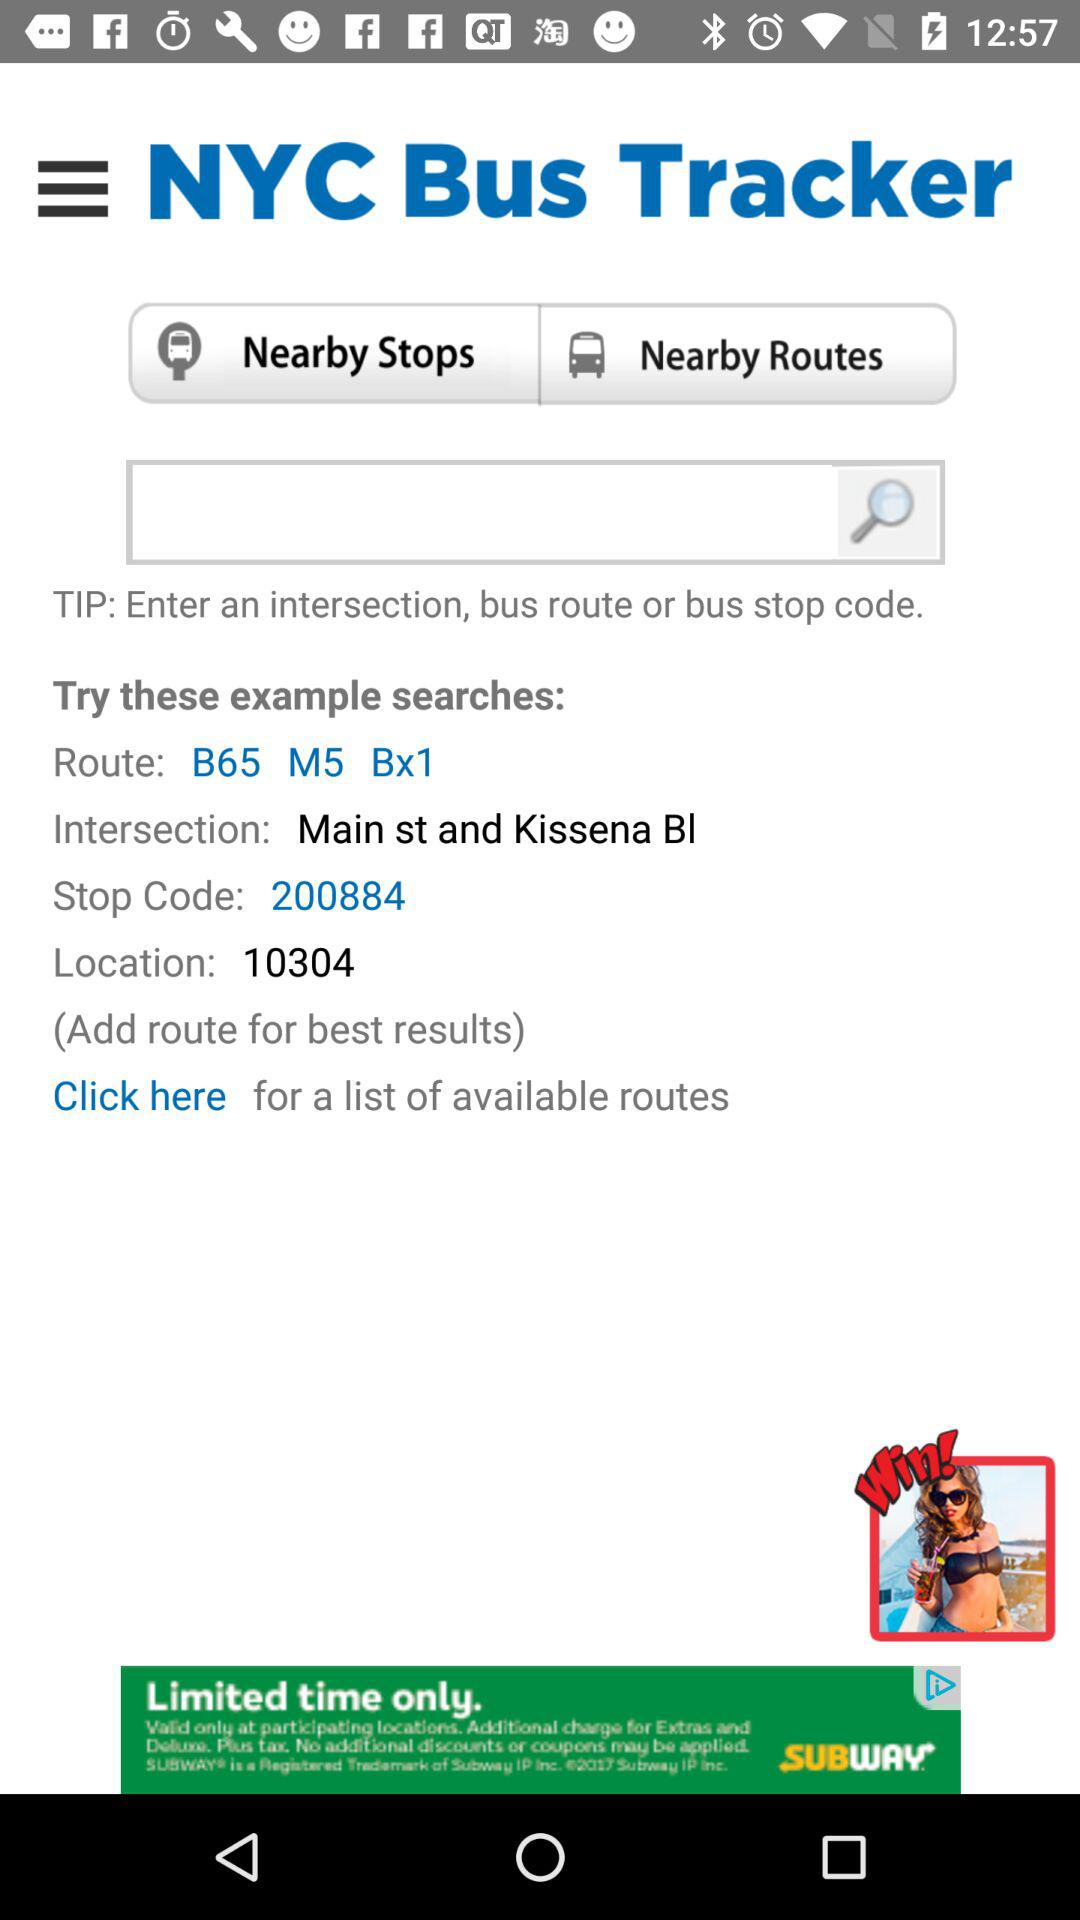What is the stop code? The stop code is 200884. 